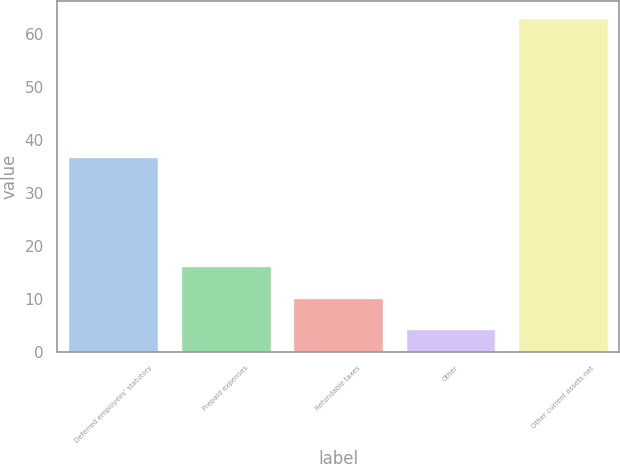<chart> <loc_0><loc_0><loc_500><loc_500><bar_chart><fcel>Deferred employees' statutory<fcel>Prepaid expenses<fcel>Refundable taxes<fcel>Other<fcel>Other current assets net<nl><fcel>36.8<fcel>16.1<fcel>10.08<fcel>4.2<fcel>63<nl></chart> 